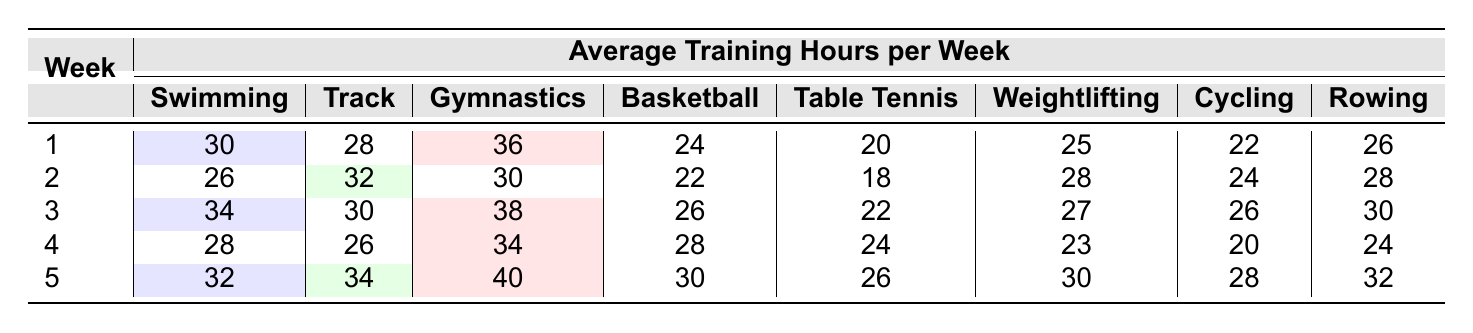What are the average training hours for Swimming in week 1? The table shows that the average training hours for Swimming in week 1 is 30 hours.
Answer: 30 Which discipline had the highest average training hours in week 5? In week 5, the highest average training hours is 40, which is for Gymnastics.
Answer: 40 How many total hours of training do athletes in Rowing do across all weeks? Adding the Rowing training hours from all weeks (26 + 28 + 30 + 24 + 32) gives a total of 140 hours.
Answer: 140 Is the average training hours for Table Tennis in week 2 greater than in week 3? The average for Table Tennis in week 2 is 18 hours, and in week 3 it is 22 hours; therefore, it is not greater.
Answer: No Which discipline consistently trained the most in week 1 and week 2 combined? For combined average hours in week 1 (Swimming: 30, Track: 28, Gymnastics: 36, Basketball: 24, Table Tennis: 20, Weightlifting: 25, Cycling: 22, Rowing: 26), the total is 64 for Gymnastics. In week 2, it has 30 hours. Gymnastics has the highest total of 94 hours combined.
Answer: Gymnastics What is the average training hours for Weightlifting over all weeks? First, sum up the Weightlifting hours: (25 + 28 + 27 + 23 + 30) = 133. Then, divide by 5 weeks: 133 / 5 = 26.6.
Answer: 26.6 In which week did Basketball have its lowest average training hours? Looking at the table, Basketball had its lowest average training hours of 20 in week 3.
Answer: Week 3 Which two disciplines had the same average training hours in week 2? In week 2, both Swimming and Cycling had the same training hours of 26.
Answer: Swimming and Cycling What was the difference in average training hours between Track and Weightlifting in week 4? In week 4, Track had 26 hours, and Weightlifting had 23 hours. The difference is 26 - 23 = 3 hours.
Answer: 3 Determine the average value of training hours across all disciplines in week 3. The training hours for week 3 are (34 + 30 + 38 + 26 + 22 + 27 + 26 + 30), summing these gives  233 hours. Then divide by 8 disciplines to find the average: 233 / 8 = 29.125.
Answer: 29.125 Are the average training hours for Cycling generally greater than 25 hours in all weeks? Cycling training hours were (22, 24, 26, 20, 28). Since week 4 has 20 hours, it is not always greater than 25.
Answer: No 